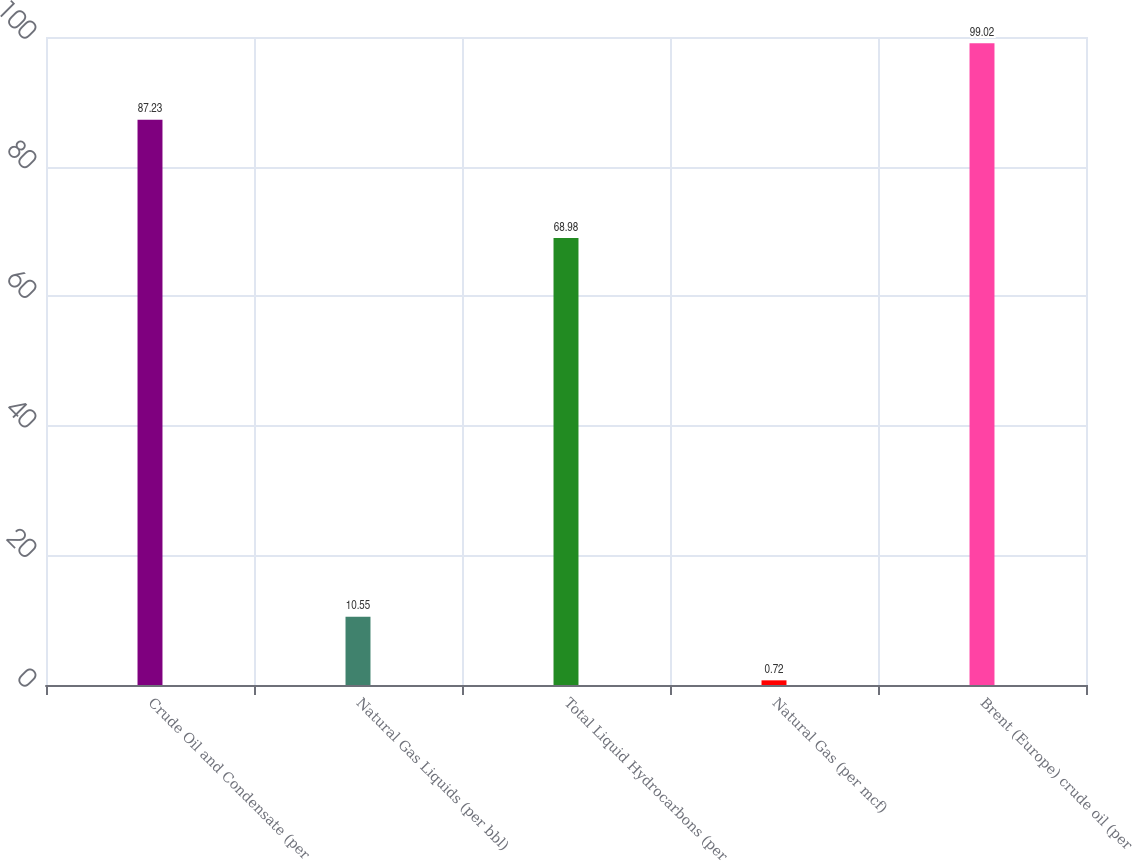<chart> <loc_0><loc_0><loc_500><loc_500><bar_chart><fcel>Crude Oil and Condensate (per<fcel>Natural Gas Liquids (per bbl)<fcel>Total Liquid Hydrocarbons (per<fcel>Natural Gas (per mcf)<fcel>Brent (Europe) crude oil (per<nl><fcel>87.23<fcel>10.55<fcel>68.98<fcel>0.72<fcel>99.02<nl></chart> 